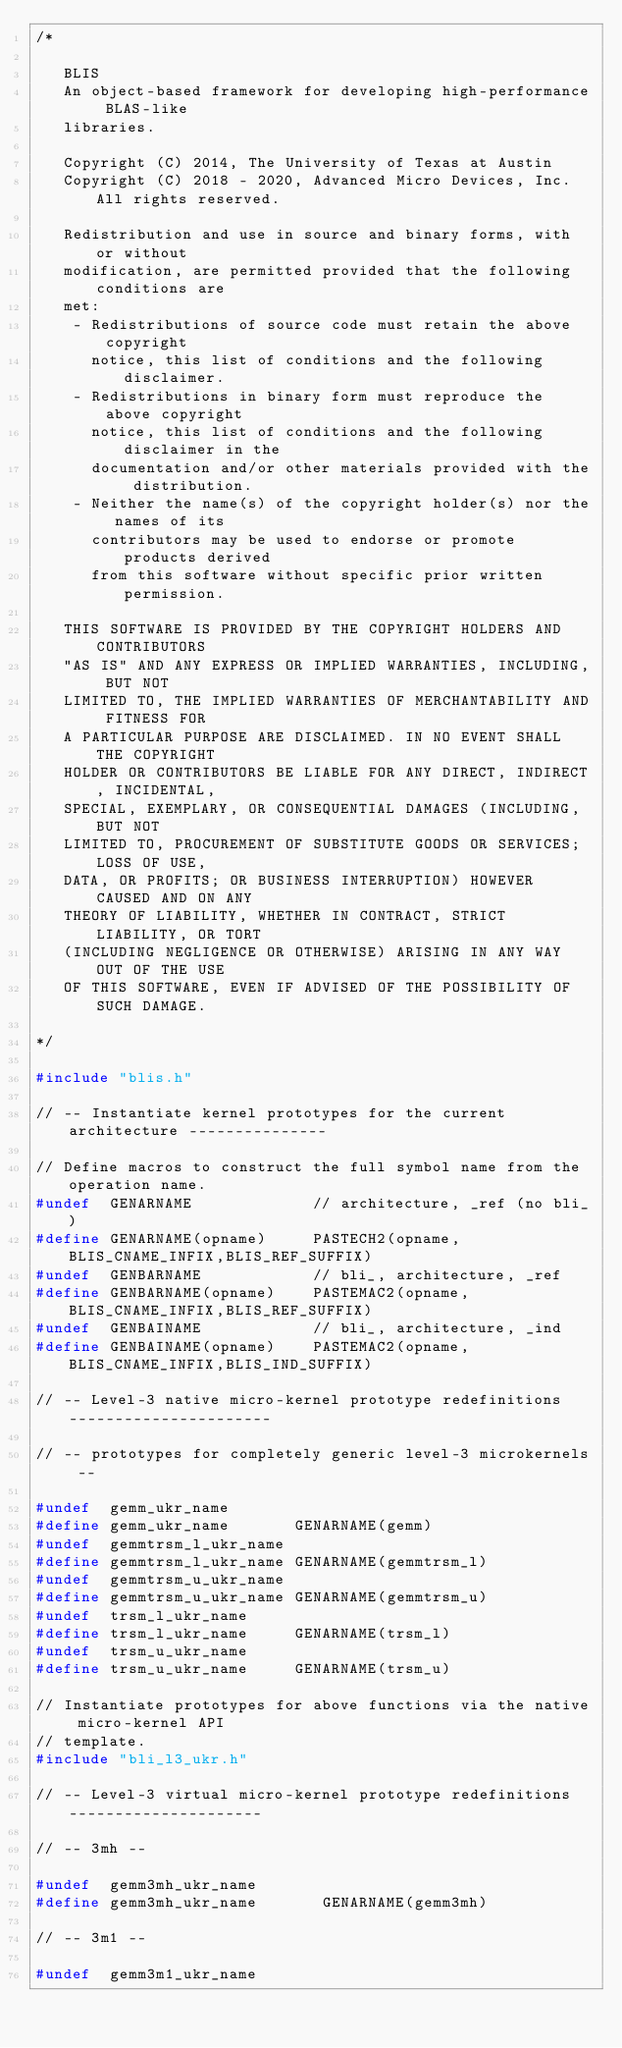<code> <loc_0><loc_0><loc_500><loc_500><_C_>/*

   BLIS
   An object-based framework for developing high-performance BLAS-like
   libraries.

   Copyright (C) 2014, The University of Texas at Austin
   Copyright (C) 2018 - 2020, Advanced Micro Devices, Inc. All rights reserved.

   Redistribution and use in source and binary forms, with or without
   modification, are permitted provided that the following conditions are
   met:
    - Redistributions of source code must retain the above copyright
      notice, this list of conditions and the following disclaimer.
    - Redistributions in binary form must reproduce the above copyright
      notice, this list of conditions and the following disclaimer in the
      documentation and/or other materials provided with the distribution.
    - Neither the name(s) of the copyright holder(s) nor the names of its
      contributors may be used to endorse or promote products derived
      from this software without specific prior written permission.

   THIS SOFTWARE IS PROVIDED BY THE COPYRIGHT HOLDERS AND CONTRIBUTORS
   "AS IS" AND ANY EXPRESS OR IMPLIED WARRANTIES, INCLUDING, BUT NOT
   LIMITED TO, THE IMPLIED WARRANTIES OF MERCHANTABILITY AND FITNESS FOR
   A PARTICULAR PURPOSE ARE DISCLAIMED. IN NO EVENT SHALL THE COPYRIGHT
   HOLDER OR CONTRIBUTORS BE LIABLE FOR ANY DIRECT, INDIRECT, INCIDENTAL,
   SPECIAL, EXEMPLARY, OR CONSEQUENTIAL DAMAGES (INCLUDING, BUT NOT
   LIMITED TO, PROCUREMENT OF SUBSTITUTE GOODS OR SERVICES; LOSS OF USE,
   DATA, OR PROFITS; OR BUSINESS INTERRUPTION) HOWEVER CAUSED AND ON ANY
   THEORY OF LIABILITY, WHETHER IN CONTRACT, STRICT LIABILITY, OR TORT
   (INCLUDING NEGLIGENCE OR OTHERWISE) ARISING IN ANY WAY OUT OF THE USE
   OF THIS SOFTWARE, EVEN IF ADVISED OF THE POSSIBILITY OF SUCH DAMAGE.

*/

#include "blis.h"

// -- Instantiate kernel prototypes for the current architecture ---------------

// Define macros to construct the full symbol name from the operation name.
#undef  GENARNAME             // architecture, _ref (no bli_)
#define GENARNAME(opname)     PASTECH2(opname,BLIS_CNAME_INFIX,BLIS_REF_SUFFIX)
#undef  GENBARNAME            // bli_, architecture, _ref
#define GENBARNAME(opname)    PASTEMAC2(opname,BLIS_CNAME_INFIX,BLIS_REF_SUFFIX)
#undef  GENBAINAME            // bli_, architecture, _ind
#define GENBAINAME(opname)    PASTEMAC2(opname,BLIS_CNAME_INFIX,BLIS_IND_SUFFIX)

// -- Level-3 native micro-kernel prototype redefinitions ----------------------

// -- prototypes for completely generic level-3 microkernels --

#undef  gemm_ukr_name
#define gemm_ukr_name       GENARNAME(gemm)
#undef  gemmtrsm_l_ukr_name
#define gemmtrsm_l_ukr_name GENARNAME(gemmtrsm_l)
#undef  gemmtrsm_u_ukr_name
#define gemmtrsm_u_ukr_name GENARNAME(gemmtrsm_u)
#undef  trsm_l_ukr_name
#define trsm_l_ukr_name     GENARNAME(trsm_l)
#undef  trsm_u_ukr_name
#define trsm_u_ukr_name     GENARNAME(trsm_u)

// Instantiate prototypes for above functions via the native micro-kernel API
// template.
#include "bli_l3_ukr.h"

// -- Level-3 virtual micro-kernel prototype redefinitions ---------------------

// -- 3mh --

#undef  gemm3mh_ukr_name
#define gemm3mh_ukr_name       GENARNAME(gemm3mh)

// -- 3m1 --

#undef  gemm3m1_ukr_name</code> 